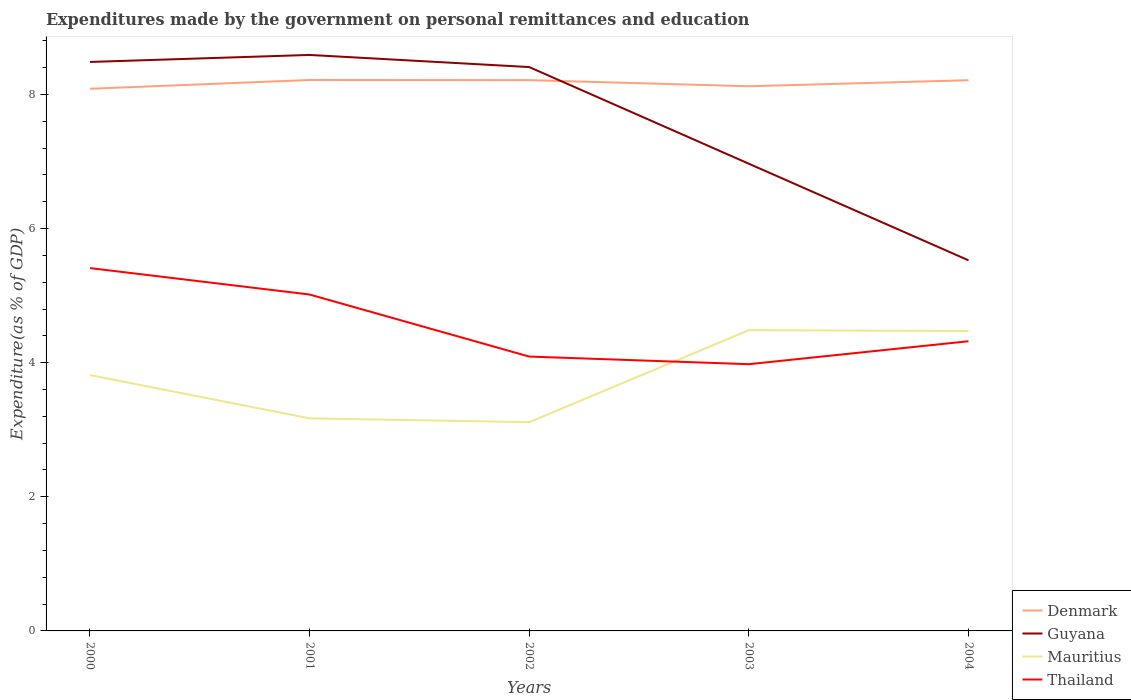Does the line corresponding to Thailand intersect with the line corresponding to Mauritius?
Your answer should be compact. Yes. Across all years, what is the maximum expenditures made by the government on personal remittances and education in Guyana?
Make the answer very short. 5.53. What is the total expenditures made by the government on personal remittances and education in Mauritius in the graph?
Provide a short and direct response. 0.65. What is the difference between the highest and the second highest expenditures made by the government on personal remittances and education in Thailand?
Make the answer very short. 1.43. Is the expenditures made by the government on personal remittances and education in Mauritius strictly greater than the expenditures made by the government on personal remittances and education in Denmark over the years?
Provide a succinct answer. Yes. What is the difference between two consecutive major ticks on the Y-axis?
Provide a short and direct response. 2. Are the values on the major ticks of Y-axis written in scientific E-notation?
Your answer should be compact. No. Does the graph contain any zero values?
Your response must be concise. No. Does the graph contain grids?
Offer a very short reply. No. Where does the legend appear in the graph?
Give a very brief answer. Bottom right. How many legend labels are there?
Provide a short and direct response. 4. What is the title of the graph?
Keep it short and to the point. Expenditures made by the government on personal remittances and education. What is the label or title of the X-axis?
Offer a terse response. Years. What is the label or title of the Y-axis?
Your response must be concise. Expenditure(as % of GDP). What is the Expenditure(as % of GDP) in Denmark in 2000?
Your answer should be compact. 8.08. What is the Expenditure(as % of GDP) in Guyana in 2000?
Your answer should be very brief. 8.48. What is the Expenditure(as % of GDP) in Mauritius in 2000?
Your response must be concise. 3.82. What is the Expenditure(as % of GDP) of Thailand in 2000?
Offer a terse response. 5.41. What is the Expenditure(as % of GDP) in Denmark in 2001?
Give a very brief answer. 8.22. What is the Expenditure(as % of GDP) of Guyana in 2001?
Provide a succinct answer. 8.59. What is the Expenditure(as % of GDP) in Mauritius in 2001?
Your response must be concise. 3.17. What is the Expenditure(as % of GDP) of Thailand in 2001?
Keep it short and to the point. 5.02. What is the Expenditure(as % of GDP) in Denmark in 2002?
Keep it short and to the point. 8.21. What is the Expenditure(as % of GDP) in Guyana in 2002?
Ensure brevity in your answer.  8.41. What is the Expenditure(as % of GDP) of Mauritius in 2002?
Your answer should be very brief. 3.11. What is the Expenditure(as % of GDP) of Thailand in 2002?
Make the answer very short. 4.09. What is the Expenditure(as % of GDP) of Denmark in 2003?
Offer a very short reply. 8.12. What is the Expenditure(as % of GDP) in Guyana in 2003?
Ensure brevity in your answer.  6.97. What is the Expenditure(as % of GDP) in Mauritius in 2003?
Keep it short and to the point. 4.48. What is the Expenditure(as % of GDP) in Thailand in 2003?
Give a very brief answer. 3.98. What is the Expenditure(as % of GDP) of Denmark in 2004?
Make the answer very short. 8.21. What is the Expenditure(as % of GDP) of Guyana in 2004?
Provide a succinct answer. 5.53. What is the Expenditure(as % of GDP) of Mauritius in 2004?
Offer a very short reply. 4.47. What is the Expenditure(as % of GDP) in Thailand in 2004?
Ensure brevity in your answer.  4.32. Across all years, what is the maximum Expenditure(as % of GDP) in Denmark?
Provide a short and direct response. 8.22. Across all years, what is the maximum Expenditure(as % of GDP) in Guyana?
Offer a terse response. 8.59. Across all years, what is the maximum Expenditure(as % of GDP) in Mauritius?
Offer a very short reply. 4.48. Across all years, what is the maximum Expenditure(as % of GDP) of Thailand?
Your answer should be very brief. 5.41. Across all years, what is the minimum Expenditure(as % of GDP) of Denmark?
Your answer should be very brief. 8.08. Across all years, what is the minimum Expenditure(as % of GDP) in Guyana?
Keep it short and to the point. 5.53. Across all years, what is the minimum Expenditure(as % of GDP) of Mauritius?
Offer a terse response. 3.11. Across all years, what is the minimum Expenditure(as % of GDP) in Thailand?
Keep it short and to the point. 3.98. What is the total Expenditure(as % of GDP) in Denmark in the graph?
Provide a short and direct response. 40.85. What is the total Expenditure(as % of GDP) in Guyana in the graph?
Give a very brief answer. 37.97. What is the total Expenditure(as % of GDP) in Mauritius in the graph?
Make the answer very short. 19.05. What is the total Expenditure(as % of GDP) in Thailand in the graph?
Provide a short and direct response. 22.81. What is the difference between the Expenditure(as % of GDP) in Denmark in 2000 and that in 2001?
Your response must be concise. -0.13. What is the difference between the Expenditure(as % of GDP) of Guyana in 2000 and that in 2001?
Make the answer very short. -0.1. What is the difference between the Expenditure(as % of GDP) in Mauritius in 2000 and that in 2001?
Make the answer very short. 0.65. What is the difference between the Expenditure(as % of GDP) of Thailand in 2000 and that in 2001?
Ensure brevity in your answer.  0.39. What is the difference between the Expenditure(as % of GDP) of Denmark in 2000 and that in 2002?
Provide a short and direct response. -0.13. What is the difference between the Expenditure(as % of GDP) in Guyana in 2000 and that in 2002?
Provide a succinct answer. 0.08. What is the difference between the Expenditure(as % of GDP) of Mauritius in 2000 and that in 2002?
Offer a terse response. 0.7. What is the difference between the Expenditure(as % of GDP) of Thailand in 2000 and that in 2002?
Keep it short and to the point. 1.32. What is the difference between the Expenditure(as % of GDP) in Denmark in 2000 and that in 2003?
Keep it short and to the point. -0.04. What is the difference between the Expenditure(as % of GDP) in Guyana in 2000 and that in 2003?
Give a very brief answer. 1.52. What is the difference between the Expenditure(as % of GDP) in Mauritius in 2000 and that in 2003?
Provide a short and direct response. -0.67. What is the difference between the Expenditure(as % of GDP) of Thailand in 2000 and that in 2003?
Provide a succinct answer. 1.43. What is the difference between the Expenditure(as % of GDP) of Denmark in 2000 and that in 2004?
Make the answer very short. -0.13. What is the difference between the Expenditure(as % of GDP) in Guyana in 2000 and that in 2004?
Provide a succinct answer. 2.96. What is the difference between the Expenditure(as % of GDP) of Mauritius in 2000 and that in 2004?
Your answer should be very brief. -0.66. What is the difference between the Expenditure(as % of GDP) in Thailand in 2000 and that in 2004?
Provide a short and direct response. 1.09. What is the difference between the Expenditure(as % of GDP) of Denmark in 2001 and that in 2002?
Your answer should be compact. 0. What is the difference between the Expenditure(as % of GDP) in Guyana in 2001 and that in 2002?
Keep it short and to the point. 0.18. What is the difference between the Expenditure(as % of GDP) of Mauritius in 2001 and that in 2002?
Offer a very short reply. 0.06. What is the difference between the Expenditure(as % of GDP) of Thailand in 2001 and that in 2002?
Keep it short and to the point. 0.93. What is the difference between the Expenditure(as % of GDP) in Denmark in 2001 and that in 2003?
Your answer should be compact. 0.09. What is the difference between the Expenditure(as % of GDP) of Guyana in 2001 and that in 2003?
Provide a short and direct response. 1.62. What is the difference between the Expenditure(as % of GDP) of Mauritius in 2001 and that in 2003?
Give a very brief answer. -1.31. What is the difference between the Expenditure(as % of GDP) of Thailand in 2001 and that in 2003?
Make the answer very short. 1.04. What is the difference between the Expenditure(as % of GDP) in Denmark in 2001 and that in 2004?
Provide a short and direct response. 0. What is the difference between the Expenditure(as % of GDP) of Guyana in 2001 and that in 2004?
Make the answer very short. 3.06. What is the difference between the Expenditure(as % of GDP) of Mauritius in 2001 and that in 2004?
Ensure brevity in your answer.  -1.3. What is the difference between the Expenditure(as % of GDP) of Thailand in 2001 and that in 2004?
Provide a succinct answer. 0.7. What is the difference between the Expenditure(as % of GDP) of Denmark in 2002 and that in 2003?
Give a very brief answer. 0.09. What is the difference between the Expenditure(as % of GDP) in Guyana in 2002 and that in 2003?
Your response must be concise. 1.44. What is the difference between the Expenditure(as % of GDP) in Mauritius in 2002 and that in 2003?
Your answer should be compact. -1.37. What is the difference between the Expenditure(as % of GDP) of Thailand in 2002 and that in 2003?
Give a very brief answer. 0.11. What is the difference between the Expenditure(as % of GDP) in Denmark in 2002 and that in 2004?
Offer a very short reply. 0. What is the difference between the Expenditure(as % of GDP) of Guyana in 2002 and that in 2004?
Keep it short and to the point. 2.88. What is the difference between the Expenditure(as % of GDP) in Mauritius in 2002 and that in 2004?
Offer a terse response. -1.36. What is the difference between the Expenditure(as % of GDP) of Thailand in 2002 and that in 2004?
Give a very brief answer. -0.23. What is the difference between the Expenditure(as % of GDP) of Denmark in 2003 and that in 2004?
Provide a succinct answer. -0.09. What is the difference between the Expenditure(as % of GDP) in Guyana in 2003 and that in 2004?
Offer a terse response. 1.44. What is the difference between the Expenditure(as % of GDP) of Mauritius in 2003 and that in 2004?
Provide a succinct answer. 0.01. What is the difference between the Expenditure(as % of GDP) in Thailand in 2003 and that in 2004?
Provide a succinct answer. -0.34. What is the difference between the Expenditure(as % of GDP) in Denmark in 2000 and the Expenditure(as % of GDP) in Guyana in 2001?
Make the answer very short. -0.5. What is the difference between the Expenditure(as % of GDP) in Denmark in 2000 and the Expenditure(as % of GDP) in Mauritius in 2001?
Your answer should be compact. 4.91. What is the difference between the Expenditure(as % of GDP) of Denmark in 2000 and the Expenditure(as % of GDP) of Thailand in 2001?
Offer a very short reply. 3.07. What is the difference between the Expenditure(as % of GDP) in Guyana in 2000 and the Expenditure(as % of GDP) in Mauritius in 2001?
Provide a succinct answer. 5.31. What is the difference between the Expenditure(as % of GDP) of Guyana in 2000 and the Expenditure(as % of GDP) of Thailand in 2001?
Keep it short and to the point. 3.47. What is the difference between the Expenditure(as % of GDP) of Mauritius in 2000 and the Expenditure(as % of GDP) of Thailand in 2001?
Ensure brevity in your answer.  -1.2. What is the difference between the Expenditure(as % of GDP) in Denmark in 2000 and the Expenditure(as % of GDP) in Guyana in 2002?
Keep it short and to the point. -0.32. What is the difference between the Expenditure(as % of GDP) of Denmark in 2000 and the Expenditure(as % of GDP) of Mauritius in 2002?
Ensure brevity in your answer.  4.97. What is the difference between the Expenditure(as % of GDP) in Denmark in 2000 and the Expenditure(as % of GDP) in Thailand in 2002?
Give a very brief answer. 3.99. What is the difference between the Expenditure(as % of GDP) of Guyana in 2000 and the Expenditure(as % of GDP) of Mauritius in 2002?
Make the answer very short. 5.37. What is the difference between the Expenditure(as % of GDP) in Guyana in 2000 and the Expenditure(as % of GDP) in Thailand in 2002?
Your response must be concise. 4.39. What is the difference between the Expenditure(as % of GDP) in Mauritius in 2000 and the Expenditure(as % of GDP) in Thailand in 2002?
Your response must be concise. -0.28. What is the difference between the Expenditure(as % of GDP) of Denmark in 2000 and the Expenditure(as % of GDP) of Guyana in 2003?
Make the answer very short. 1.12. What is the difference between the Expenditure(as % of GDP) in Denmark in 2000 and the Expenditure(as % of GDP) in Mauritius in 2003?
Your answer should be compact. 3.6. What is the difference between the Expenditure(as % of GDP) of Denmark in 2000 and the Expenditure(as % of GDP) of Thailand in 2003?
Offer a terse response. 4.11. What is the difference between the Expenditure(as % of GDP) in Guyana in 2000 and the Expenditure(as % of GDP) in Mauritius in 2003?
Your answer should be compact. 4. What is the difference between the Expenditure(as % of GDP) of Guyana in 2000 and the Expenditure(as % of GDP) of Thailand in 2003?
Provide a succinct answer. 4.51. What is the difference between the Expenditure(as % of GDP) in Mauritius in 2000 and the Expenditure(as % of GDP) in Thailand in 2003?
Your answer should be compact. -0.16. What is the difference between the Expenditure(as % of GDP) of Denmark in 2000 and the Expenditure(as % of GDP) of Guyana in 2004?
Offer a very short reply. 2.56. What is the difference between the Expenditure(as % of GDP) of Denmark in 2000 and the Expenditure(as % of GDP) of Mauritius in 2004?
Keep it short and to the point. 3.61. What is the difference between the Expenditure(as % of GDP) of Denmark in 2000 and the Expenditure(as % of GDP) of Thailand in 2004?
Offer a terse response. 3.76. What is the difference between the Expenditure(as % of GDP) in Guyana in 2000 and the Expenditure(as % of GDP) in Mauritius in 2004?
Keep it short and to the point. 4.01. What is the difference between the Expenditure(as % of GDP) of Guyana in 2000 and the Expenditure(as % of GDP) of Thailand in 2004?
Your response must be concise. 4.16. What is the difference between the Expenditure(as % of GDP) of Mauritius in 2000 and the Expenditure(as % of GDP) of Thailand in 2004?
Offer a very short reply. -0.5. What is the difference between the Expenditure(as % of GDP) in Denmark in 2001 and the Expenditure(as % of GDP) in Guyana in 2002?
Offer a very short reply. -0.19. What is the difference between the Expenditure(as % of GDP) in Denmark in 2001 and the Expenditure(as % of GDP) in Mauritius in 2002?
Ensure brevity in your answer.  5.1. What is the difference between the Expenditure(as % of GDP) in Denmark in 2001 and the Expenditure(as % of GDP) in Thailand in 2002?
Offer a terse response. 4.12. What is the difference between the Expenditure(as % of GDP) of Guyana in 2001 and the Expenditure(as % of GDP) of Mauritius in 2002?
Make the answer very short. 5.48. What is the difference between the Expenditure(as % of GDP) of Guyana in 2001 and the Expenditure(as % of GDP) of Thailand in 2002?
Provide a succinct answer. 4.5. What is the difference between the Expenditure(as % of GDP) of Mauritius in 2001 and the Expenditure(as % of GDP) of Thailand in 2002?
Give a very brief answer. -0.92. What is the difference between the Expenditure(as % of GDP) in Denmark in 2001 and the Expenditure(as % of GDP) in Guyana in 2003?
Provide a short and direct response. 1.25. What is the difference between the Expenditure(as % of GDP) in Denmark in 2001 and the Expenditure(as % of GDP) in Mauritius in 2003?
Provide a short and direct response. 3.73. What is the difference between the Expenditure(as % of GDP) of Denmark in 2001 and the Expenditure(as % of GDP) of Thailand in 2003?
Give a very brief answer. 4.24. What is the difference between the Expenditure(as % of GDP) of Guyana in 2001 and the Expenditure(as % of GDP) of Mauritius in 2003?
Provide a short and direct response. 4.1. What is the difference between the Expenditure(as % of GDP) in Guyana in 2001 and the Expenditure(as % of GDP) in Thailand in 2003?
Ensure brevity in your answer.  4.61. What is the difference between the Expenditure(as % of GDP) in Mauritius in 2001 and the Expenditure(as % of GDP) in Thailand in 2003?
Keep it short and to the point. -0.81. What is the difference between the Expenditure(as % of GDP) in Denmark in 2001 and the Expenditure(as % of GDP) in Guyana in 2004?
Offer a terse response. 2.69. What is the difference between the Expenditure(as % of GDP) of Denmark in 2001 and the Expenditure(as % of GDP) of Mauritius in 2004?
Your response must be concise. 3.74. What is the difference between the Expenditure(as % of GDP) in Denmark in 2001 and the Expenditure(as % of GDP) in Thailand in 2004?
Give a very brief answer. 3.9. What is the difference between the Expenditure(as % of GDP) in Guyana in 2001 and the Expenditure(as % of GDP) in Mauritius in 2004?
Give a very brief answer. 4.12. What is the difference between the Expenditure(as % of GDP) of Guyana in 2001 and the Expenditure(as % of GDP) of Thailand in 2004?
Your answer should be very brief. 4.27. What is the difference between the Expenditure(as % of GDP) in Mauritius in 2001 and the Expenditure(as % of GDP) in Thailand in 2004?
Provide a succinct answer. -1.15. What is the difference between the Expenditure(as % of GDP) in Denmark in 2002 and the Expenditure(as % of GDP) in Guyana in 2003?
Ensure brevity in your answer.  1.25. What is the difference between the Expenditure(as % of GDP) of Denmark in 2002 and the Expenditure(as % of GDP) of Mauritius in 2003?
Ensure brevity in your answer.  3.73. What is the difference between the Expenditure(as % of GDP) of Denmark in 2002 and the Expenditure(as % of GDP) of Thailand in 2003?
Provide a succinct answer. 4.24. What is the difference between the Expenditure(as % of GDP) in Guyana in 2002 and the Expenditure(as % of GDP) in Mauritius in 2003?
Keep it short and to the point. 3.92. What is the difference between the Expenditure(as % of GDP) of Guyana in 2002 and the Expenditure(as % of GDP) of Thailand in 2003?
Offer a very short reply. 4.43. What is the difference between the Expenditure(as % of GDP) in Mauritius in 2002 and the Expenditure(as % of GDP) in Thailand in 2003?
Make the answer very short. -0.86. What is the difference between the Expenditure(as % of GDP) in Denmark in 2002 and the Expenditure(as % of GDP) in Guyana in 2004?
Give a very brief answer. 2.69. What is the difference between the Expenditure(as % of GDP) of Denmark in 2002 and the Expenditure(as % of GDP) of Mauritius in 2004?
Give a very brief answer. 3.74. What is the difference between the Expenditure(as % of GDP) in Denmark in 2002 and the Expenditure(as % of GDP) in Thailand in 2004?
Keep it short and to the point. 3.89. What is the difference between the Expenditure(as % of GDP) in Guyana in 2002 and the Expenditure(as % of GDP) in Mauritius in 2004?
Make the answer very short. 3.94. What is the difference between the Expenditure(as % of GDP) of Guyana in 2002 and the Expenditure(as % of GDP) of Thailand in 2004?
Your response must be concise. 4.09. What is the difference between the Expenditure(as % of GDP) of Mauritius in 2002 and the Expenditure(as % of GDP) of Thailand in 2004?
Make the answer very short. -1.21. What is the difference between the Expenditure(as % of GDP) in Denmark in 2003 and the Expenditure(as % of GDP) in Guyana in 2004?
Offer a terse response. 2.6. What is the difference between the Expenditure(as % of GDP) in Denmark in 2003 and the Expenditure(as % of GDP) in Mauritius in 2004?
Your answer should be very brief. 3.65. What is the difference between the Expenditure(as % of GDP) of Denmark in 2003 and the Expenditure(as % of GDP) of Thailand in 2004?
Offer a terse response. 3.8. What is the difference between the Expenditure(as % of GDP) in Guyana in 2003 and the Expenditure(as % of GDP) in Mauritius in 2004?
Provide a succinct answer. 2.49. What is the difference between the Expenditure(as % of GDP) in Guyana in 2003 and the Expenditure(as % of GDP) in Thailand in 2004?
Ensure brevity in your answer.  2.65. What is the difference between the Expenditure(as % of GDP) in Mauritius in 2003 and the Expenditure(as % of GDP) in Thailand in 2004?
Your response must be concise. 0.16. What is the average Expenditure(as % of GDP) of Denmark per year?
Your answer should be compact. 8.17. What is the average Expenditure(as % of GDP) of Guyana per year?
Ensure brevity in your answer.  7.59. What is the average Expenditure(as % of GDP) in Mauritius per year?
Give a very brief answer. 3.81. What is the average Expenditure(as % of GDP) in Thailand per year?
Your answer should be very brief. 4.56. In the year 2000, what is the difference between the Expenditure(as % of GDP) in Denmark and Expenditure(as % of GDP) in Guyana?
Your response must be concise. -0.4. In the year 2000, what is the difference between the Expenditure(as % of GDP) of Denmark and Expenditure(as % of GDP) of Mauritius?
Provide a short and direct response. 4.27. In the year 2000, what is the difference between the Expenditure(as % of GDP) in Denmark and Expenditure(as % of GDP) in Thailand?
Give a very brief answer. 2.67. In the year 2000, what is the difference between the Expenditure(as % of GDP) of Guyana and Expenditure(as % of GDP) of Mauritius?
Provide a succinct answer. 4.67. In the year 2000, what is the difference between the Expenditure(as % of GDP) of Guyana and Expenditure(as % of GDP) of Thailand?
Your response must be concise. 3.07. In the year 2000, what is the difference between the Expenditure(as % of GDP) of Mauritius and Expenditure(as % of GDP) of Thailand?
Provide a short and direct response. -1.6. In the year 2001, what is the difference between the Expenditure(as % of GDP) of Denmark and Expenditure(as % of GDP) of Guyana?
Give a very brief answer. -0.37. In the year 2001, what is the difference between the Expenditure(as % of GDP) in Denmark and Expenditure(as % of GDP) in Mauritius?
Your answer should be very brief. 5.05. In the year 2001, what is the difference between the Expenditure(as % of GDP) of Denmark and Expenditure(as % of GDP) of Thailand?
Offer a terse response. 3.2. In the year 2001, what is the difference between the Expenditure(as % of GDP) of Guyana and Expenditure(as % of GDP) of Mauritius?
Provide a succinct answer. 5.42. In the year 2001, what is the difference between the Expenditure(as % of GDP) of Guyana and Expenditure(as % of GDP) of Thailand?
Ensure brevity in your answer.  3.57. In the year 2001, what is the difference between the Expenditure(as % of GDP) in Mauritius and Expenditure(as % of GDP) in Thailand?
Provide a short and direct response. -1.85. In the year 2002, what is the difference between the Expenditure(as % of GDP) of Denmark and Expenditure(as % of GDP) of Guyana?
Keep it short and to the point. -0.2. In the year 2002, what is the difference between the Expenditure(as % of GDP) of Denmark and Expenditure(as % of GDP) of Mauritius?
Give a very brief answer. 5.1. In the year 2002, what is the difference between the Expenditure(as % of GDP) of Denmark and Expenditure(as % of GDP) of Thailand?
Keep it short and to the point. 4.12. In the year 2002, what is the difference between the Expenditure(as % of GDP) in Guyana and Expenditure(as % of GDP) in Mauritius?
Ensure brevity in your answer.  5.3. In the year 2002, what is the difference between the Expenditure(as % of GDP) of Guyana and Expenditure(as % of GDP) of Thailand?
Provide a succinct answer. 4.32. In the year 2002, what is the difference between the Expenditure(as % of GDP) in Mauritius and Expenditure(as % of GDP) in Thailand?
Provide a short and direct response. -0.98. In the year 2003, what is the difference between the Expenditure(as % of GDP) in Denmark and Expenditure(as % of GDP) in Guyana?
Offer a terse response. 1.16. In the year 2003, what is the difference between the Expenditure(as % of GDP) in Denmark and Expenditure(as % of GDP) in Mauritius?
Offer a very short reply. 3.64. In the year 2003, what is the difference between the Expenditure(as % of GDP) in Denmark and Expenditure(as % of GDP) in Thailand?
Give a very brief answer. 4.14. In the year 2003, what is the difference between the Expenditure(as % of GDP) of Guyana and Expenditure(as % of GDP) of Mauritius?
Your answer should be very brief. 2.48. In the year 2003, what is the difference between the Expenditure(as % of GDP) in Guyana and Expenditure(as % of GDP) in Thailand?
Make the answer very short. 2.99. In the year 2003, what is the difference between the Expenditure(as % of GDP) in Mauritius and Expenditure(as % of GDP) in Thailand?
Offer a terse response. 0.51. In the year 2004, what is the difference between the Expenditure(as % of GDP) of Denmark and Expenditure(as % of GDP) of Guyana?
Ensure brevity in your answer.  2.69. In the year 2004, what is the difference between the Expenditure(as % of GDP) of Denmark and Expenditure(as % of GDP) of Mauritius?
Provide a short and direct response. 3.74. In the year 2004, what is the difference between the Expenditure(as % of GDP) of Denmark and Expenditure(as % of GDP) of Thailand?
Offer a terse response. 3.89. In the year 2004, what is the difference between the Expenditure(as % of GDP) of Guyana and Expenditure(as % of GDP) of Mauritius?
Ensure brevity in your answer.  1.05. In the year 2004, what is the difference between the Expenditure(as % of GDP) in Guyana and Expenditure(as % of GDP) in Thailand?
Make the answer very short. 1.21. In the year 2004, what is the difference between the Expenditure(as % of GDP) in Mauritius and Expenditure(as % of GDP) in Thailand?
Your answer should be very brief. 0.15. What is the ratio of the Expenditure(as % of GDP) in Denmark in 2000 to that in 2001?
Keep it short and to the point. 0.98. What is the ratio of the Expenditure(as % of GDP) of Mauritius in 2000 to that in 2001?
Provide a short and direct response. 1.2. What is the ratio of the Expenditure(as % of GDP) in Thailand in 2000 to that in 2001?
Offer a terse response. 1.08. What is the ratio of the Expenditure(as % of GDP) in Denmark in 2000 to that in 2002?
Your response must be concise. 0.98. What is the ratio of the Expenditure(as % of GDP) of Guyana in 2000 to that in 2002?
Your response must be concise. 1.01. What is the ratio of the Expenditure(as % of GDP) of Mauritius in 2000 to that in 2002?
Offer a very short reply. 1.23. What is the ratio of the Expenditure(as % of GDP) of Thailand in 2000 to that in 2002?
Ensure brevity in your answer.  1.32. What is the ratio of the Expenditure(as % of GDP) of Denmark in 2000 to that in 2003?
Your answer should be very brief. 1. What is the ratio of the Expenditure(as % of GDP) in Guyana in 2000 to that in 2003?
Offer a terse response. 1.22. What is the ratio of the Expenditure(as % of GDP) of Mauritius in 2000 to that in 2003?
Provide a succinct answer. 0.85. What is the ratio of the Expenditure(as % of GDP) in Thailand in 2000 to that in 2003?
Your response must be concise. 1.36. What is the ratio of the Expenditure(as % of GDP) of Denmark in 2000 to that in 2004?
Offer a very short reply. 0.98. What is the ratio of the Expenditure(as % of GDP) of Guyana in 2000 to that in 2004?
Ensure brevity in your answer.  1.54. What is the ratio of the Expenditure(as % of GDP) in Mauritius in 2000 to that in 2004?
Provide a succinct answer. 0.85. What is the ratio of the Expenditure(as % of GDP) in Thailand in 2000 to that in 2004?
Keep it short and to the point. 1.25. What is the ratio of the Expenditure(as % of GDP) of Denmark in 2001 to that in 2002?
Provide a short and direct response. 1. What is the ratio of the Expenditure(as % of GDP) in Guyana in 2001 to that in 2002?
Make the answer very short. 1.02. What is the ratio of the Expenditure(as % of GDP) in Mauritius in 2001 to that in 2002?
Offer a very short reply. 1.02. What is the ratio of the Expenditure(as % of GDP) in Thailand in 2001 to that in 2002?
Offer a terse response. 1.23. What is the ratio of the Expenditure(as % of GDP) of Denmark in 2001 to that in 2003?
Keep it short and to the point. 1.01. What is the ratio of the Expenditure(as % of GDP) in Guyana in 2001 to that in 2003?
Keep it short and to the point. 1.23. What is the ratio of the Expenditure(as % of GDP) in Mauritius in 2001 to that in 2003?
Your answer should be very brief. 0.71. What is the ratio of the Expenditure(as % of GDP) of Thailand in 2001 to that in 2003?
Provide a succinct answer. 1.26. What is the ratio of the Expenditure(as % of GDP) in Guyana in 2001 to that in 2004?
Offer a terse response. 1.55. What is the ratio of the Expenditure(as % of GDP) in Mauritius in 2001 to that in 2004?
Offer a terse response. 0.71. What is the ratio of the Expenditure(as % of GDP) of Thailand in 2001 to that in 2004?
Offer a very short reply. 1.16. What is the ratio of the Expenditure(as % of GDP) of Denmark in 2002 to that in 2003?
Provide a succinct answer. 1.01. What is the ratio of the Expenditure(as % of GDP) in Guyana in 2002 to that in 2003?
Ensure brevity in your answer.  1.21. What is the ratio of the Expenditure(as % of GDP) in Mauritius in 2002 to that in 2003?
Give a very brief answer. 0.69. What is the ratio of the Expenditure(as % of GDP) of Thailand in 2002 to that in 2003?
Give a very brief answer. 1.03. What is the ratio of the Expenditure(as % of GDP) in Denmark in 2002 to that in 2004?
Make the answer very short. 1. What is the ratio of the Expenditure(as % of GDP) of Guyana in 2002 to that in 2004?
Your response must be concise. 1.52. What is the ratio of the Expenditure(as % of GDP) of Mauritius in 2002 to that in 2004?
Provide a short and direct response. 0.7. What is the ratio of the Expenditure(as % of GDP) in Thailand in 2002 to that in 2004?
Provide a short and direct response. 0.95. What is the ratio of the Expenditure(as % of GDP) of Denmark in 2003 to that in 2004?
Ensure brevity in your answer.  0.99. What is the ratio of the Expenditure(as % of GDP) in Guyana in 2003 to that in 2004?
Provide a succinct answer. 1.26. What is the ratio of the Expenditure(as % of GDP) of Thailand in 2003 to that in 2004?
Your response must be concise. 0.92. What is the difference between the highest and the second highest Expenditure(as % of GDP) of Denmark?
Ensure brevity in your answer.  0. What is the difference between the highest and the second highest Expenditure(as % of GDP) of Guyana?
Keep it short and to the point. 0.1. What is the difference between the highest and the second highest Expenditure(as % of GDP) of Mauritius?
Provide a succinct answer. 0.01. What is the difference between the highest and the second highest Expenditure(as % of GDP) of Thailand?
Ensure brevity in your answer.  0.39. What is the difference between the highest and the lowest Expenditure(as % of GDP) of Denmark?
Provide a succinct answer. 0.13. What is the difference between the highest and the lowest Expenditure(as % of GDP) in Guyana?
Your answer should be compact. 3.06. What is the difference between the highest and the lowest Expenditure(as % of GDP) of Mauritius?
Make the answer very short. 1.37. What is the difference between the highest and the lowest Expenditure(as % of GDP) in Thailand?
Offer a very short reply. 1.43. 